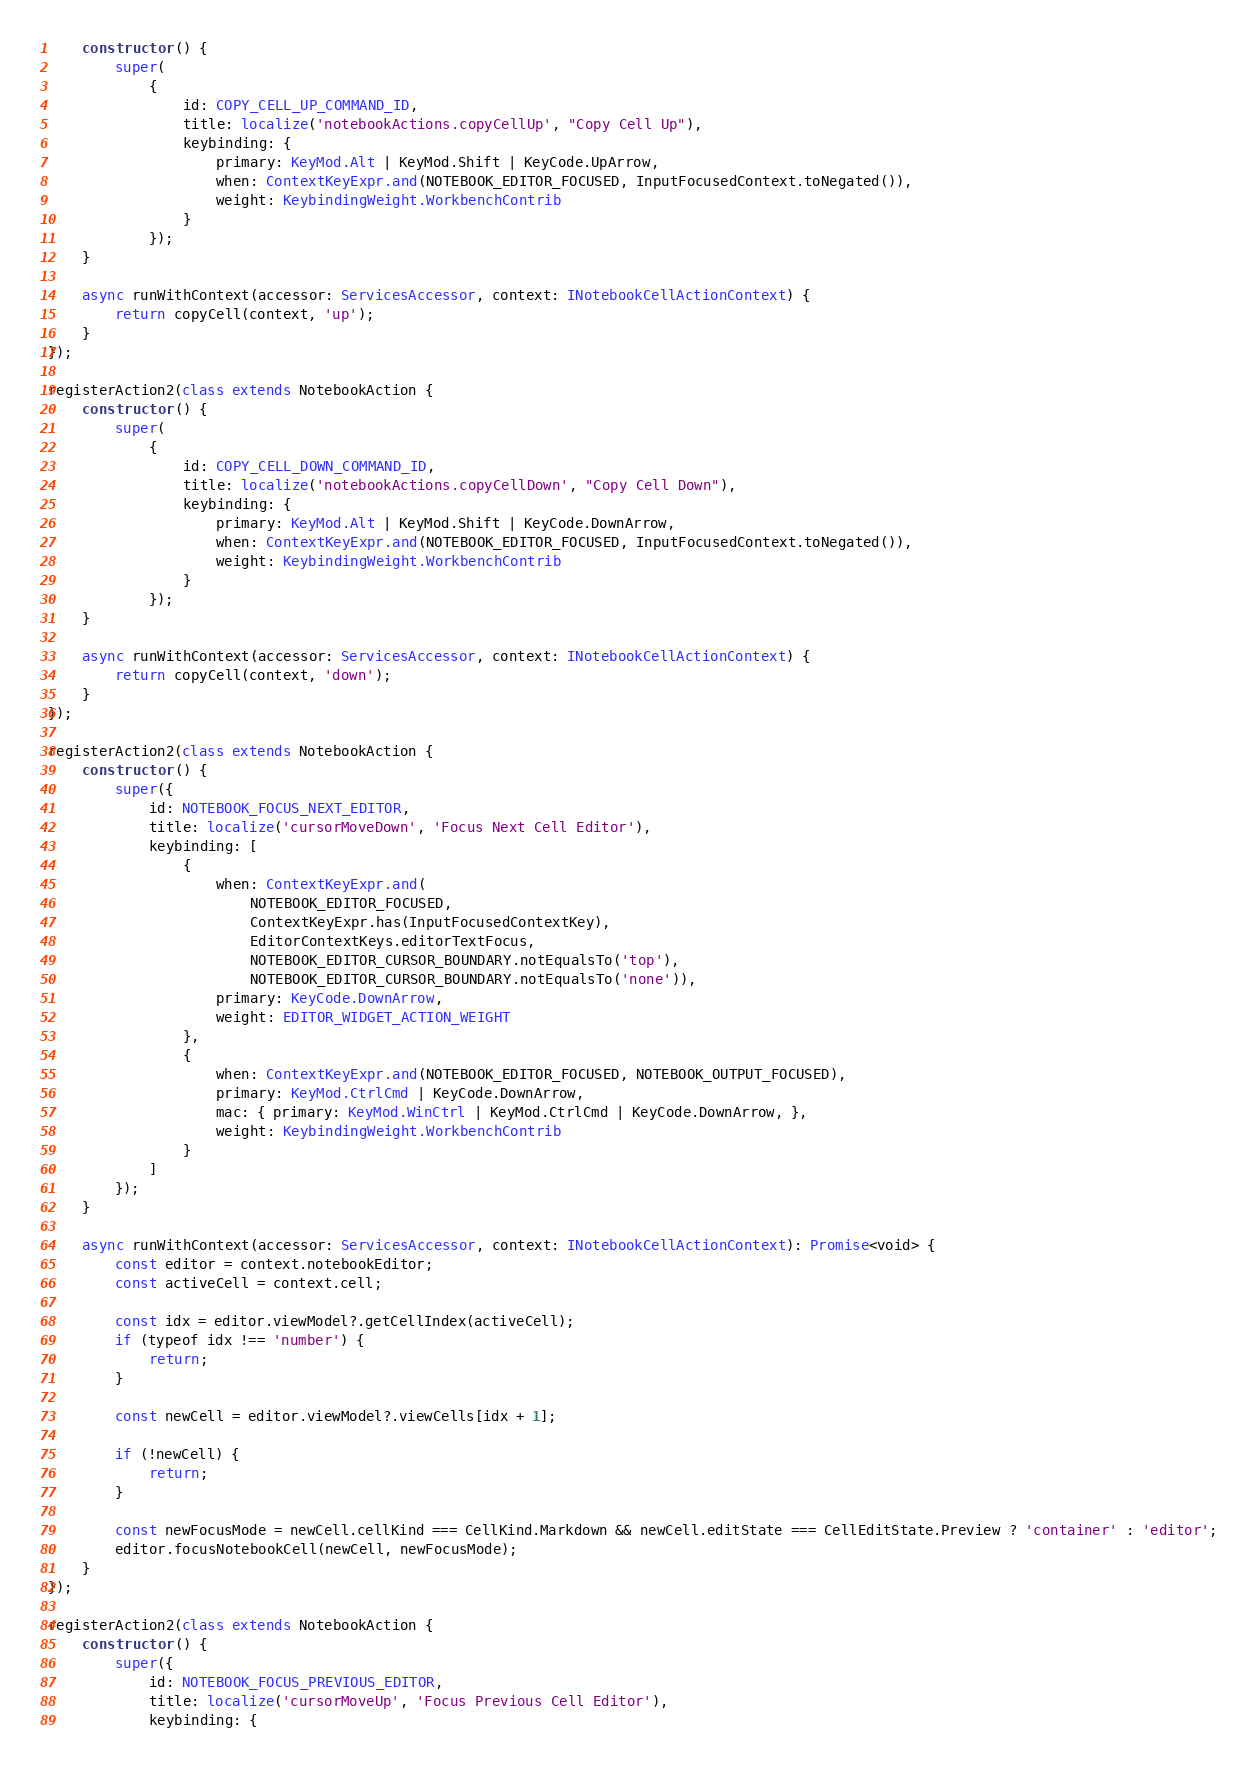Convert code to text. <code><loc_0><loc_0><loc_500><loc_500><_TypeScript_>	constructor() {
		super(
			{
				id: COPY_CELL_UP_COMMAND_ID,
				title: localize('notebookActions.copyCellUp', "Copy Cell Up"),
				keybinding: {
					primary: KeyMod.Alt | KeyMod.Shift | KeyCode.UpArrow,
					when: ContextKeyExpr.and(NOTEBOOK_EDITOR_FOCUSED, InputFocusedContext.toNegated()),
					weight: KeybindingWeight.WorkbenchContrib
				}
			});
	}

	async runWithContext(accessor: ServicesAccessor, context: INotebookCellActionContext) {
		return copyCell(context, 'up');
	}
});

registerAction2(class extends NotebookAction {
	constructor() {
		super(
			{
				id: COPY_CELL_DOWN_COMMAND_ID,
				title: localize('notebookActions.copyCellDown', "Copy Cell Down"),
				keybinding: {
					primary: KeyMod.Alt | KeyMod.Shift | KeyCode.DownArrow,
					when: ContextKeyExpr.and(NOTEBOOK_EDITOR_FOCUSED, InputFocusedContext.toNegated()),
					weight: KeybindingWeight.WorkbenchContrib
				}
			});
	}

	async runWithContext(accessor: ServicesAccessor, context: INotebookCellActionContext) {
		return copyCell(context, 'down');
	}
});

registerAction2(class extends NotebookAction {
	constructor() {
		super({
			id: NOTEBOOK_FOCUS_NEXT_EDITOR,
			title: localize('cursorMoveDown', 'Focus Next Cell Editor'),
			keybinding: [
				{
					when: ContextKeyExpr.and(
						NOTEBOOK_EDITOR_FOCUSED,
						ContextKeyExpr.has(InputFocusedContextKey),
						EditorContextKeys.editorTextFocus,
						NOTEBOOK_EDITOR_CURSOR_BOUNDARY.notEqualsTo('top'),
						NOTEBOOK_EDITOR_CURSOR_BOUNDARY.notEqualsTo('none')),
					primary: KeyCode.DownArrow,
					weight: EDITOR_WIDGET_ACTION_WEIGHT
				},
				{
					when: ContextKeyExpr.and(NOTEBOOK_EDITOR_FOCUSED, NOTEBOOK_OUTPUT_FOCUSED),
					primary: KeyMod.CtrlCmd | KeyCode.DownArrow,
					mac: { primary: KeyMod.WinCtrl | KeyMod.CtrlCmd | KeyCode.DownArrow, },
					weight: KeybindingWeight.WorkbenchContrib
				}
			]
		});
	}

	async runWithContext(accessor: ServicesAccessor, context: INotebookCellActionContext): Promise<void> {
		const editor = context.notebookEditor;
		const activeCell = context.cell;

		const idx = editor.viewModel?.getCellIndex(activeCell);
		if (typeof idx !== 'number') {
			return;
		}

		const newCell = editor.viewModel?.viewCells[idx + 1];

		if (!newCell) {
			return;
		}

		const newFocusMode = newCell.cellKind === CellKind.Markdown && newCell.editState === CellEditState.Preview ? 'container' : 'editor';
		editor.focusNotebookCell(newCell, newFocusMode);
	}
});

registerAction2(class extends NotebookAction {
	constructor() {
		super({
			id: NOTEBOOK_FOCUS_PREVIOUS_EDITOR,
			title: localize('cursorMoveUp', 'Focus Previous Cell Editor'),
			keybinding: {</code> 